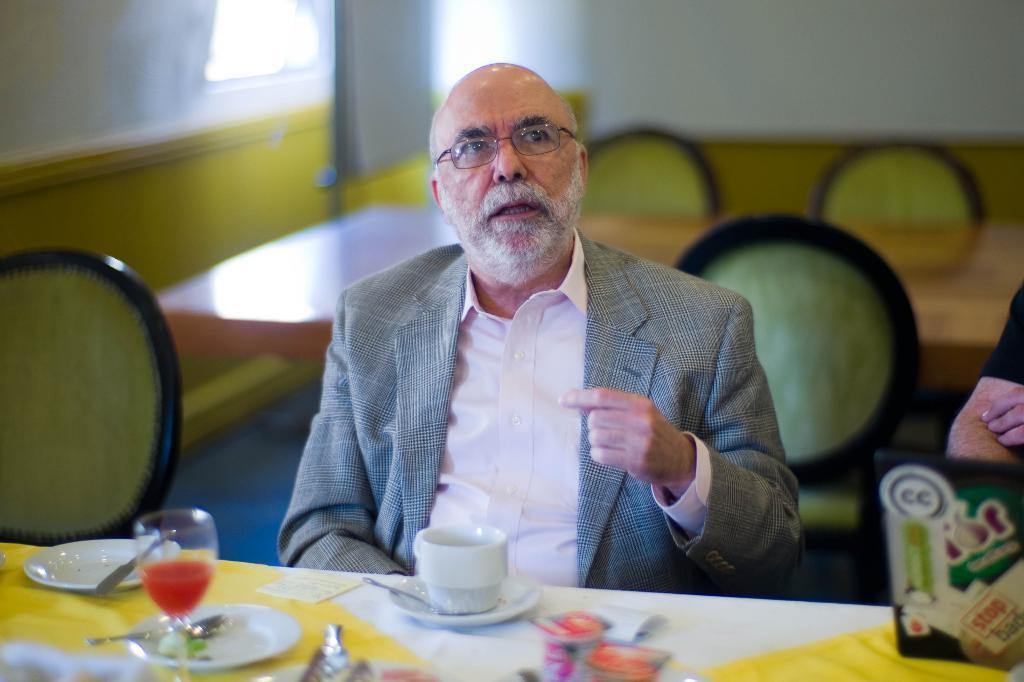Describe this image in one or two sentences. This is an image clicked inside the room. There is a man wearing suit and sitting beside the table. On the table I can see a cup, saucers and a glass. In the background there is a wall. On the right side of the image I can see a person's hand. 